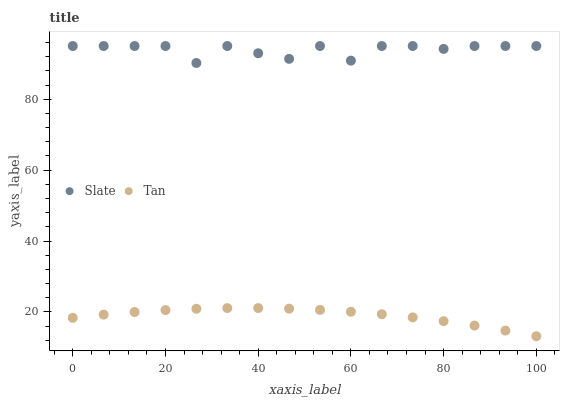Does Tan have the minimum area under the curve?
Answer yes or no. Yes. Does Slate have the maximum area under the curve?
Answer yes or no. Yes. Does Tan have the maximum area under the curve?
Answer yes or no. No. Is Tan the smoothest?
Answer yes or no. Yes. Is Slate the roughest?
Answer yes or no. Yes. Is Tan the roughest?
Answer yes or no. No. Does Tan have the lowest value?
Answer yes or no. Yes. Does Slate have the highest value?
Answer yes or no. Yes. Does Tan have the highest value?
Answer yes or no. No. Is Tan less than Slate?
Answer yes or no. Yes. Is Slate greater than Tan?
Answer yes or no. Yes. Does Tan intersect Slate?
Answer yes or no. No. 